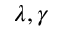Convert formula to latex. <formula><loc_0><loc_0><loc_500><loc_500>\lambda , \gamma</formula> 